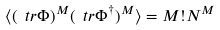<formula> <loc_0><loc_0><loc_500><loc_500>\langle ( \ t r \Phi ) ^ { M } ( \ t r \Phi ^ { \dagger } ) ^ { M } \rangle = M ! N ^ { M }</formula> 